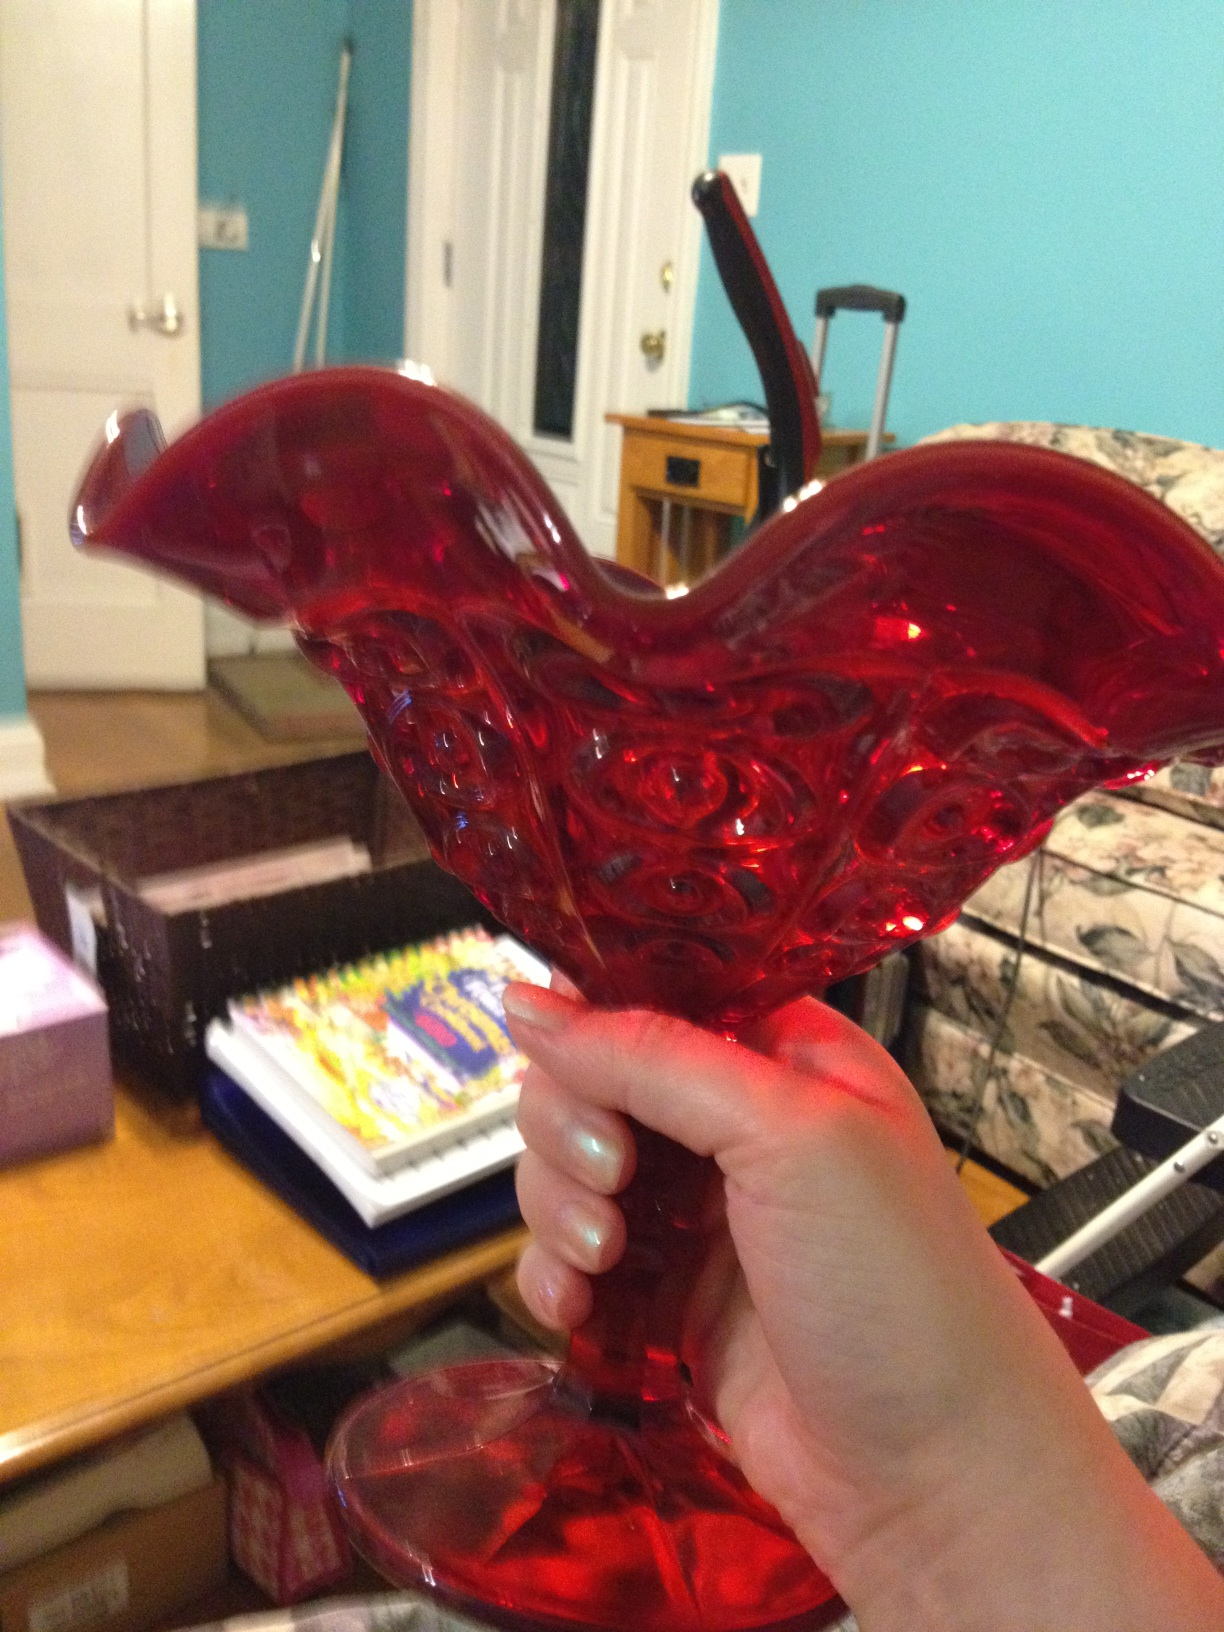What is this? This is a beautifully crafted glass vase. Its striking red color and intricate design suggest it might be used as a decorative piece, perfect for holding flowers or as a standalone ornament in a living room or dining area. 